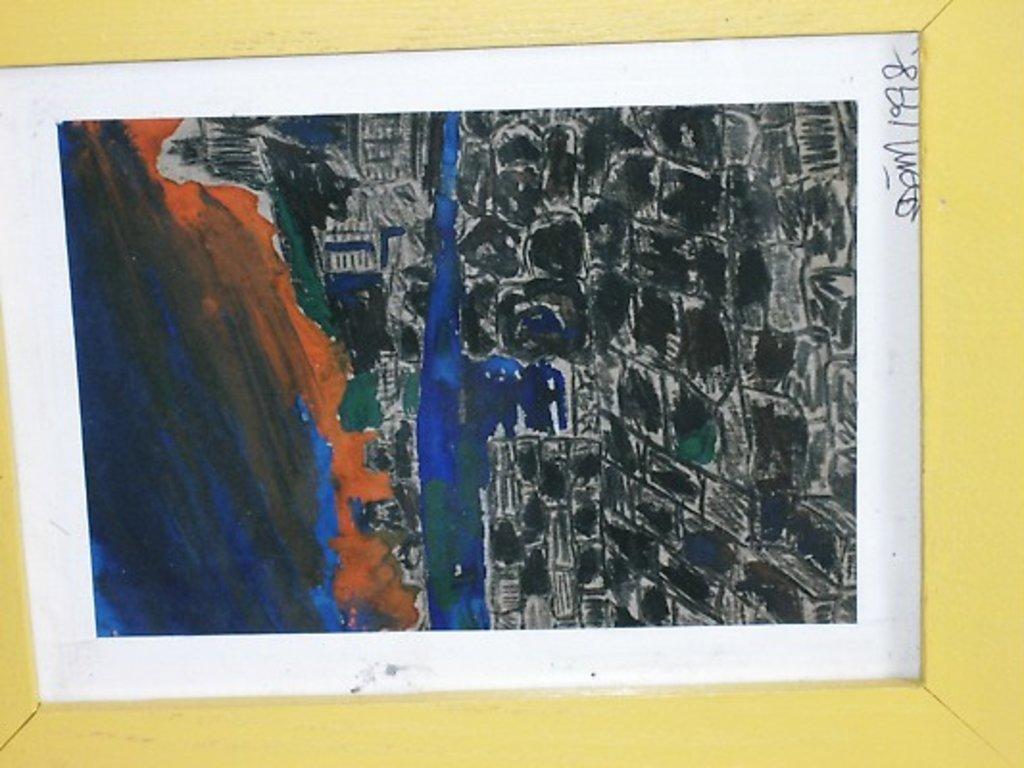Describe this image in one or two sentences. This is an image of the painting where we can see some paintings and mountains. 